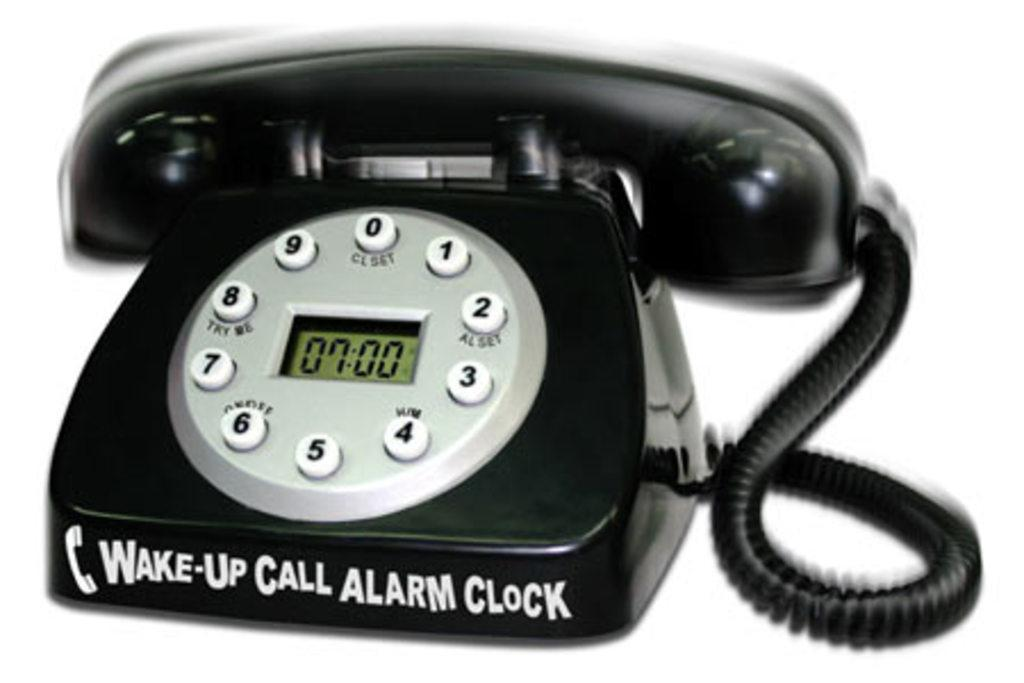<image>
Present a compact description of the photo's key features. Black telephone that says "Wake up call alarm clock " on the bottom. 